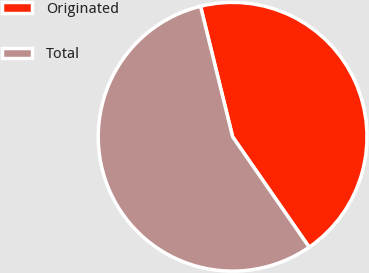Convert chart. <chart><loc_0><loc_0><loc_500><loc_500><pie_chart><fcel>Originated<fcel>Total<nl><fcel>44.19%<fcel>55.81%<nl></chart> 